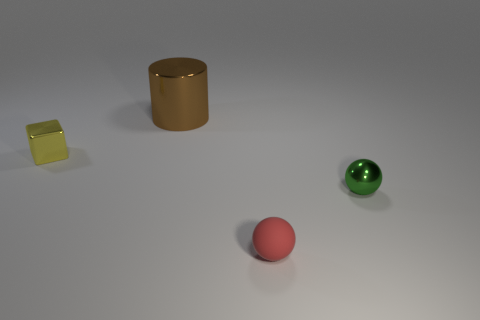Add 2 large brown objects. How many objects exist? 6 Subtract all cubes. How many objects are left? 3 Add 3 yellow shiny things. How many yellow shiny things are left? 4 Add 2 big brown metallic objects. How many big brown metallic objects exist? 3 Subtract 1 yellow cubes. How many objects are left? 3 Subtract all spheres. Subtract all big things. How many objects are left? 1 